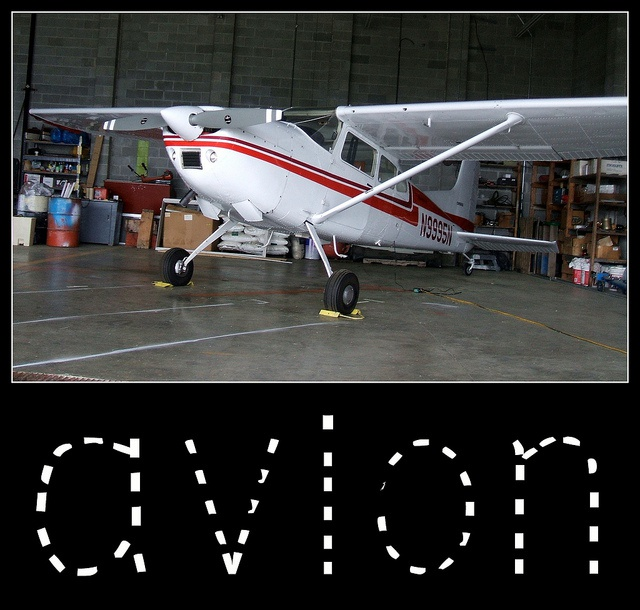Describe the objects in this image and their specific colors. I can see a airplane in black, lavender, darkgray, and gray tones in this image. 